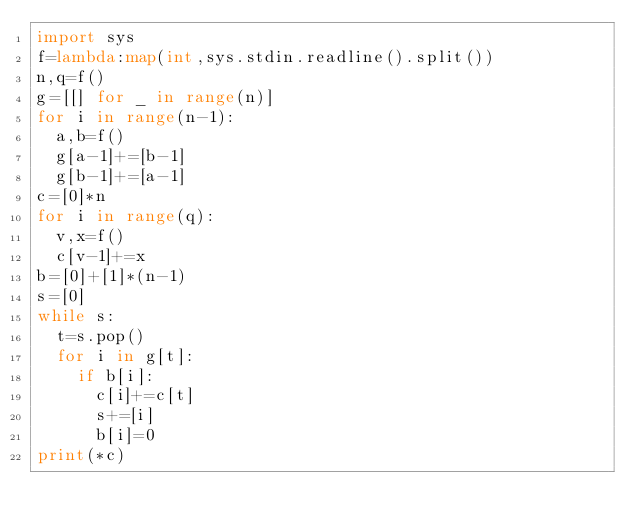Convert code to text. <code><loc_0><loc_0><loc_500><loc_500><_Python_>import sys
f=lambda:map(int,sys.stdin.readline().split())
n,q=f()
g=[[] for _ in range(n)]
for i in range(n-1):
  a,b=f()
  g[a-1]+=[b-1]
  g[b-1]+=[a-1]
c=[0]*n
for i in range(q):
  v,x=f()
  c[v-1]+=x
b=[0]+[1]*(n-1)
s=[0]
while s:
  t=s.pop()
  for i in g[t]:
    if b[i]:
      c[i]+=c[t]
      s+=[i]
      b[i]=0
print(*c)</code> 